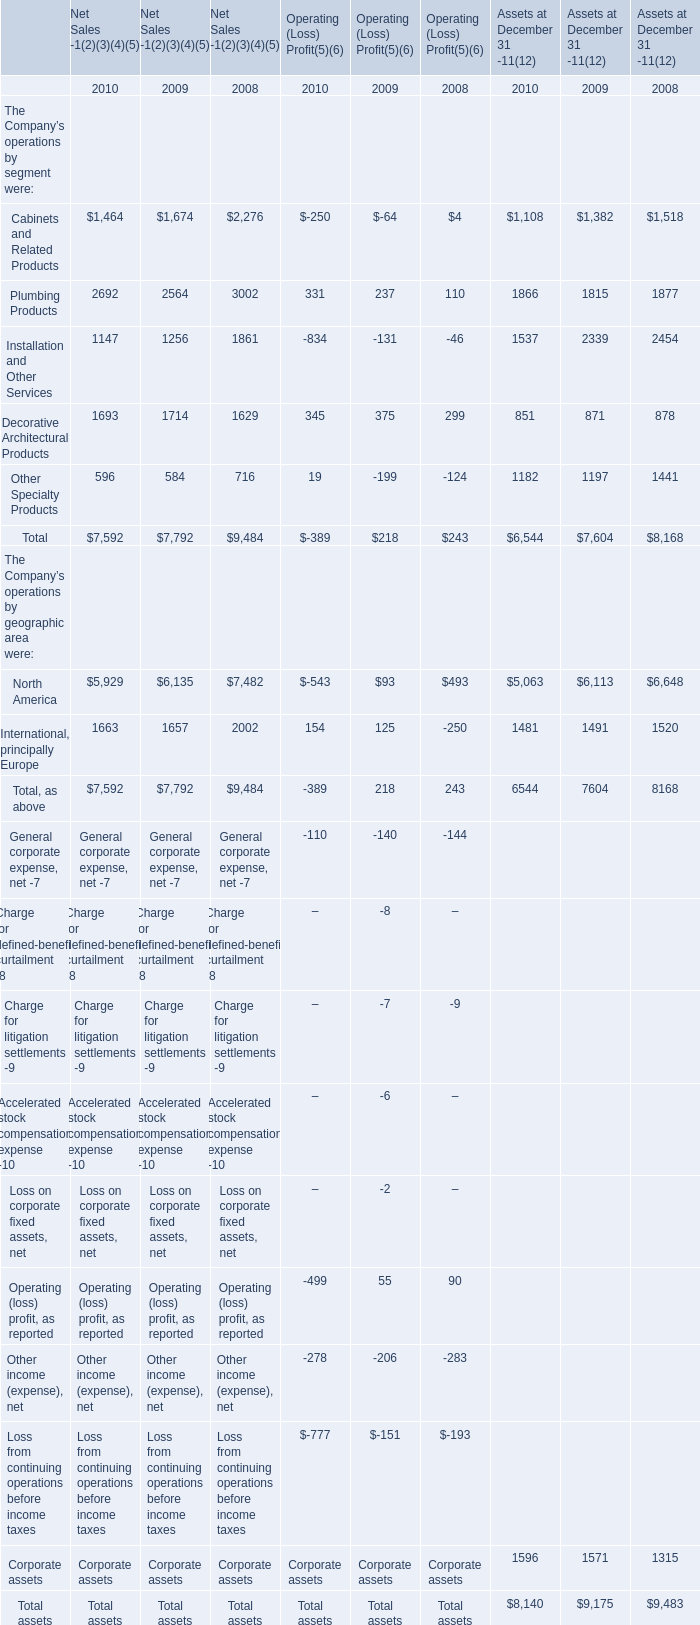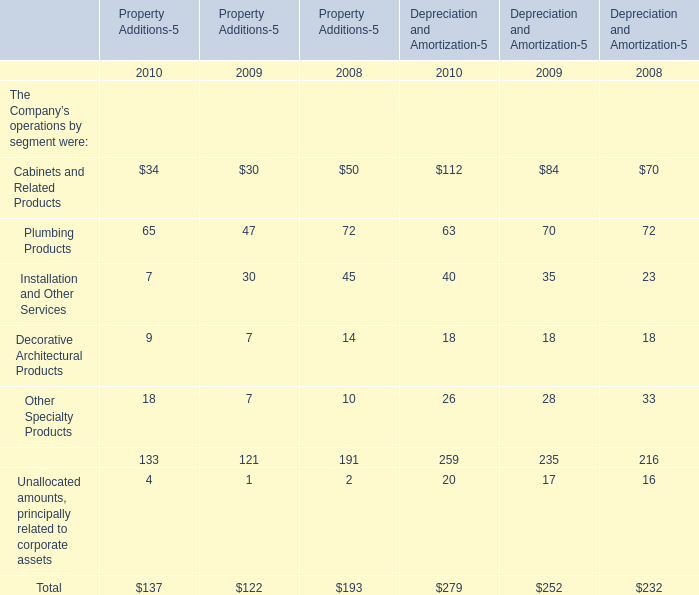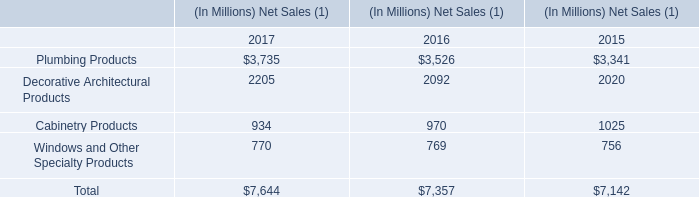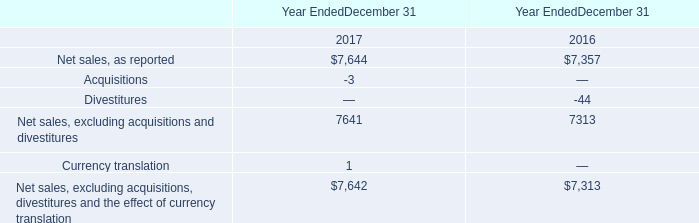Which year is Depreciation and Amortization in terms of Other Specialty Products the least? 
Answer: 2010. 